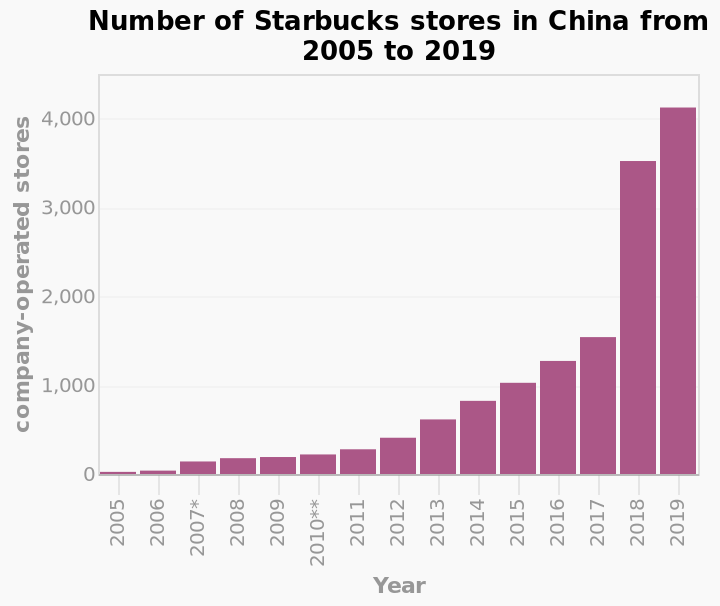<image>
What is the maximum number of Starbucks stores in China during the given period?  The maximum number of Starbucks stores in China is 4,000. 